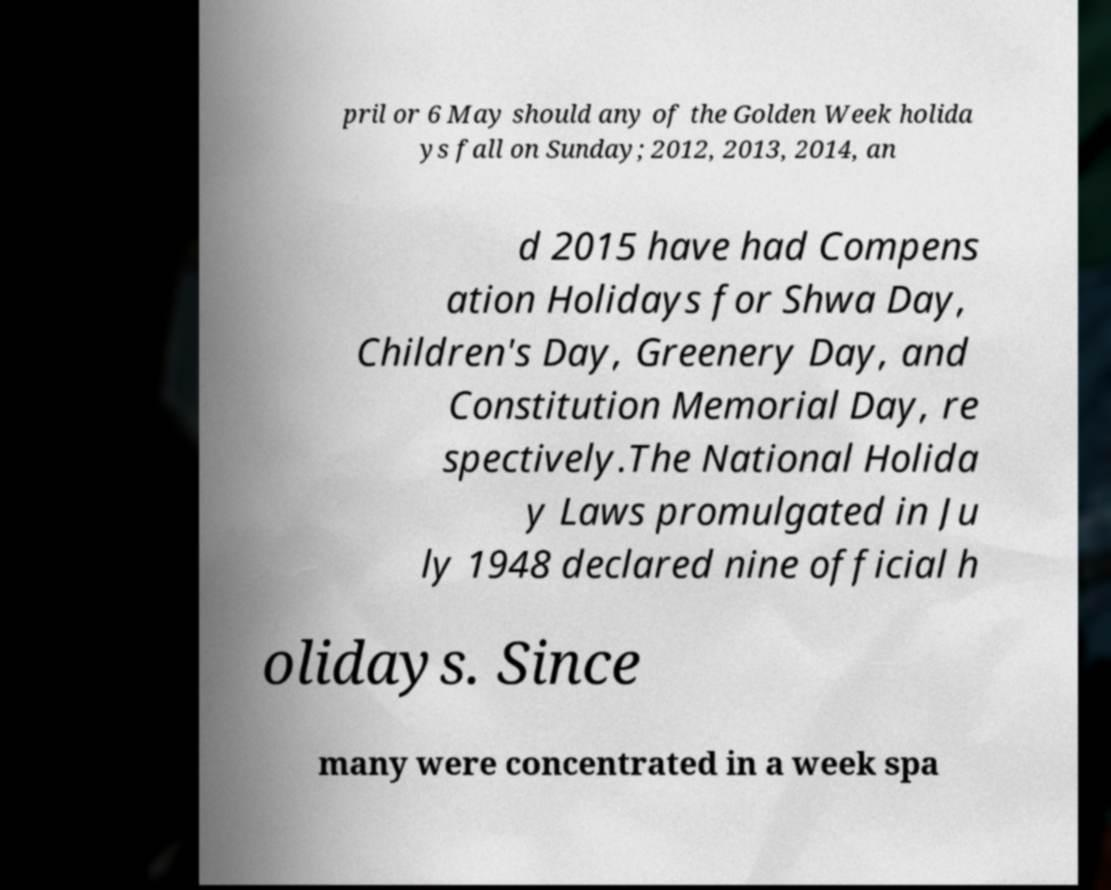For documentation purposes, I need the text within this image transcribed. Could you provide that? pril or 6 May should any of the Golden Week holida ys fall on Sunday; 2012, 2013, 2014, an d 2015 have had Compens ation Holidays for Shwa Day, Children's Day, Greenery Day, and Constitution Memorial Day, re spectively.The National Holida y Laws promulgated in Ju ly 1948 declared nine official h olidays. Since many were concentrated in a week spa 